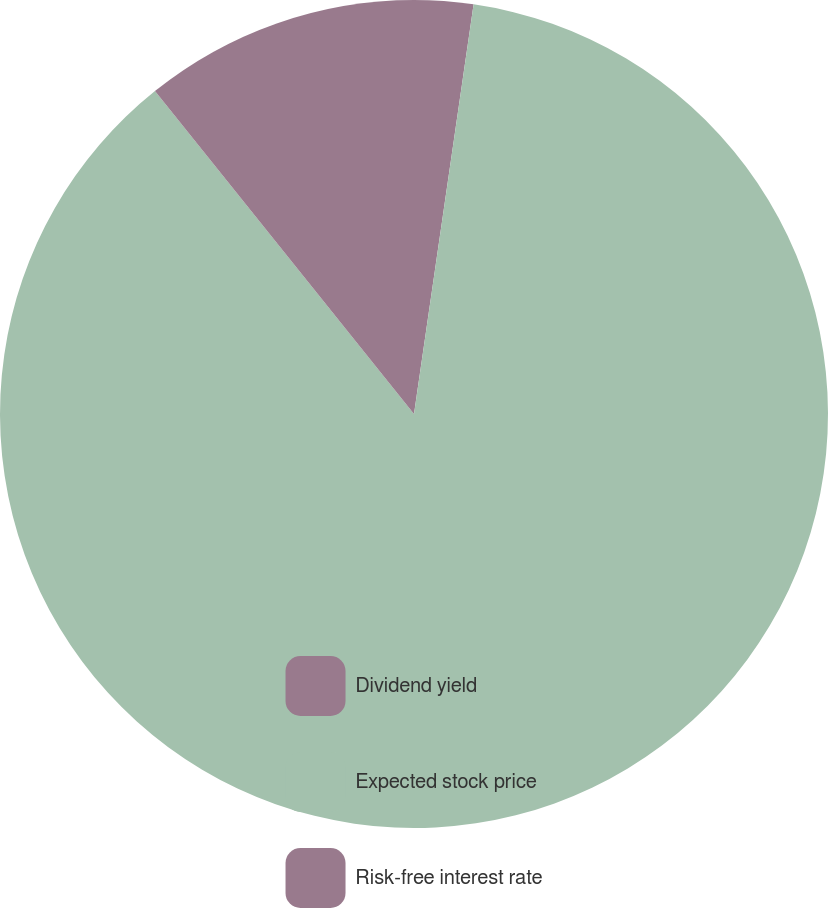Convert chart to OTSL. <chart><loc_0><loc_0><loc_500><loc_500><pie_chart><fcel>Dividend yield<fcel>Expected stock price<fcel>Risk-free interest rate<nl><fcel>2.3%<fcel>86.94%<fcel>10.76%<nl></chart> 